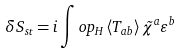Convert formula to latex. <formula><loc_0><loc_0><loc_500><loc_500>\delta S _ { s t } = i \int o p _ { H } \left \langle T _ { a b } \right \rangle \tilde { \chi } ^ { a } \varepsilon ^ { b }</formula> 